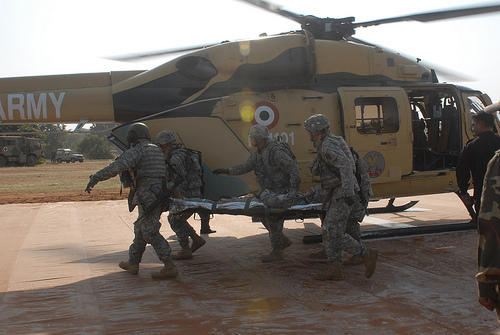<image>
Is there a man next to the stretcher? No. The man is not positioned next to the stretcher. They are located in different areas of the scene. 